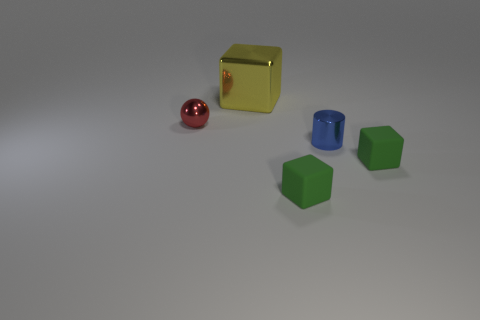Is there any other thing that is the same size as the yellow object?
Ensure brevity in your answer.  No. Are there any other things that are the same shape as the blue object?
Your response must be concise. No. Are there any tiny matte cylinders?
Your answer should be compact. No. There is a metallic object that is on the right side of the metallic cube; does it have the same size as the big yellow thing?
Your response must be concise. No. Is the number of green matte objects less than the number of blue things?
Give a very brief answer. No. What shape is the green rubber object to the right of the tiny matte block to the left of the green thing that is right of the small blue thing?
Provide a succinct answer. Cube. Is there a small red cylinder that has the same material as the yellow block?
Ensure brevity in your answer.  No. Does the tiny shiny object that is to the right of the big cube have the same color as the thing behind the small red sphere?
Ensure brevity in your answer.  No. Are there fewer spheres that are right of the blue cylinder than blue objects?
Give a very brief answer. Yes. How many objects are either small red metallic spheres or things that are right of the big yellow thing?
Make the answer very short. 4. 